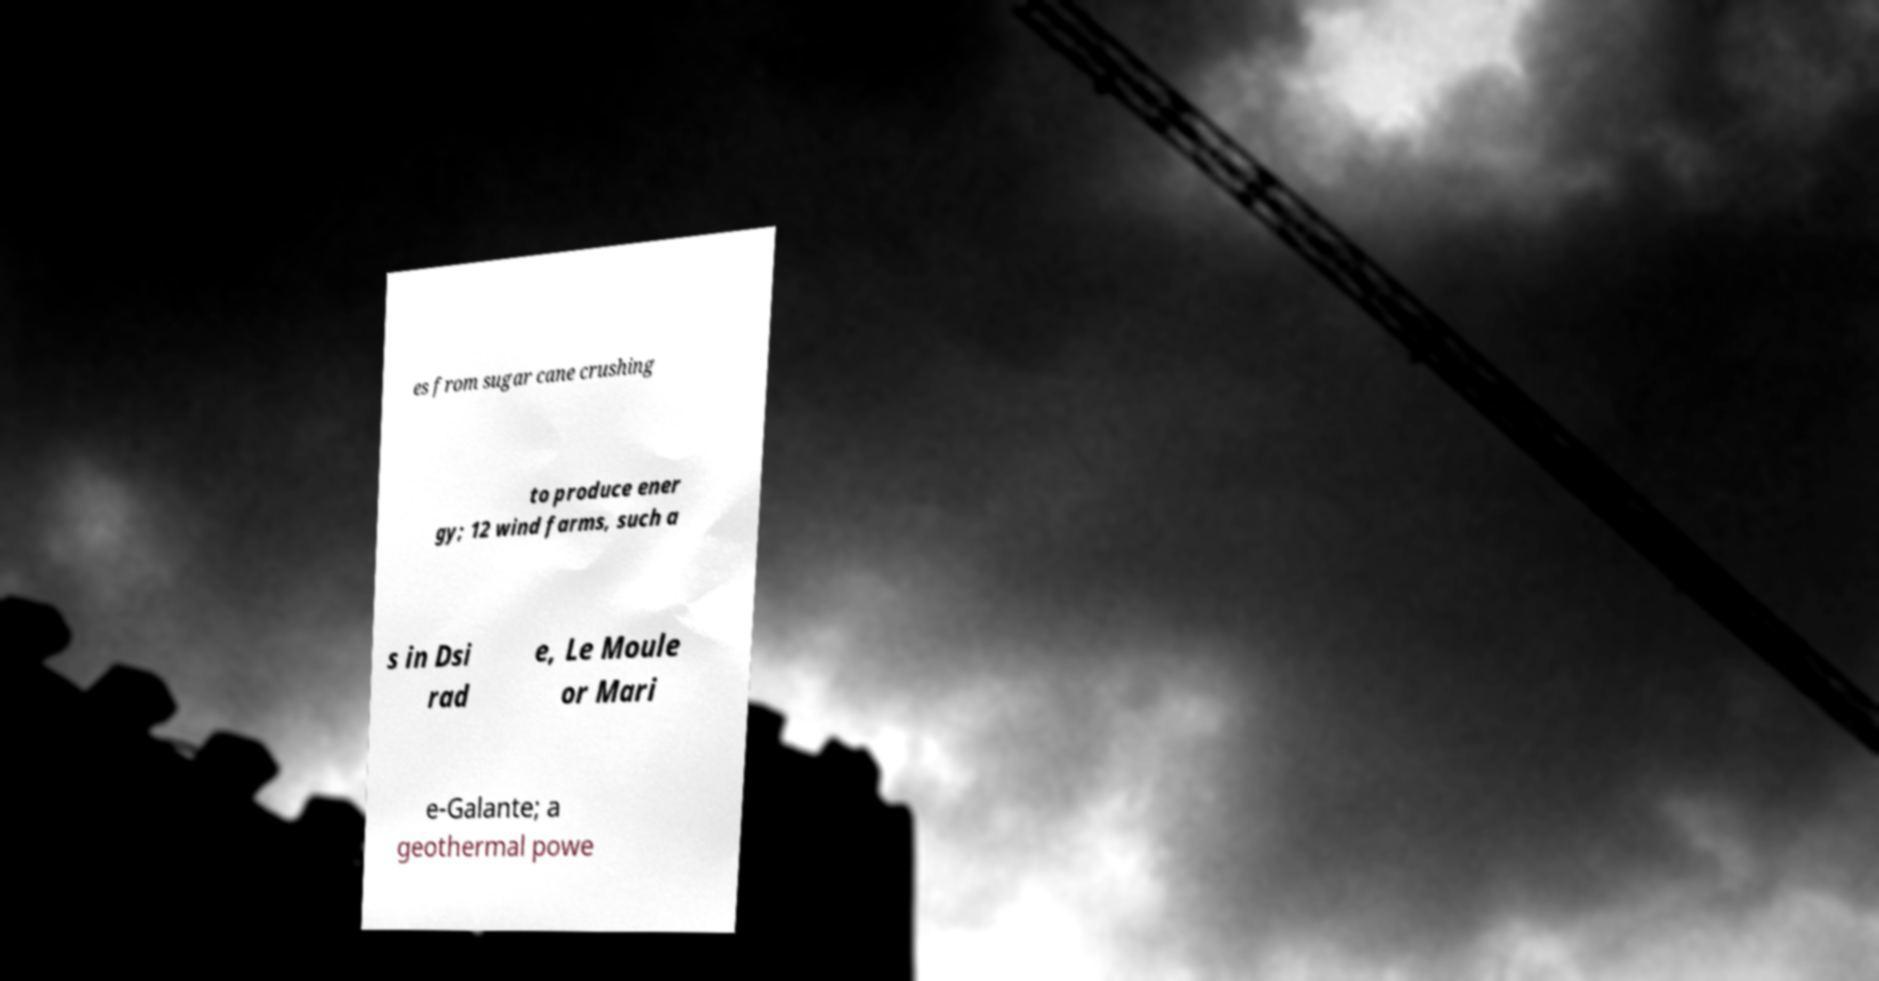Could you extract and type out the text from this image? es from sugar cane crushing to produce ener gy; 12 wind farms, such a s in Dsi rad e, Le Moule or Mari e-Galante; a geothermal powe 